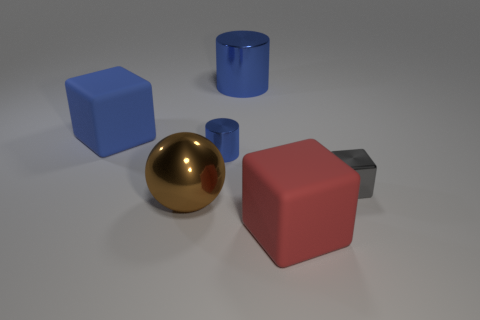Is the number of tiny objects less than the number of blue matte things?
Ensure brevity in your answer.  No. Is there any other thing of the same color as the big metallic cylinder?
Your answer should be compact. Yes. What shape is the large rubber thing behind the tiny blue shiny cylinder?
Your response must be concise. Cube. Does the tiny cylinder have the same color as the block in front of the small gray metal block?
Make the answer very short. No. Is the number of big objects on the left side of the big blue metal object the same as the number of tiny blue shiny objects left of the sphere?
Your answer should be compact. No. How many other objects are the same size as the gray metallic object?
Offer a very short reply. 1. What is the size of the red block?
Your response must be concise. Large. Does the red cube have the same material as the cube that is on the left side of the tiny blue cylinder?
Provide a succinct answer. Yes. Is there a large rubber thing of the same shape as the small gray metallic thing?
Keep it short and to the point. Yes. What is the material of the cylinder that is the same size as the sphere?
Make the answer very short. Metal. 